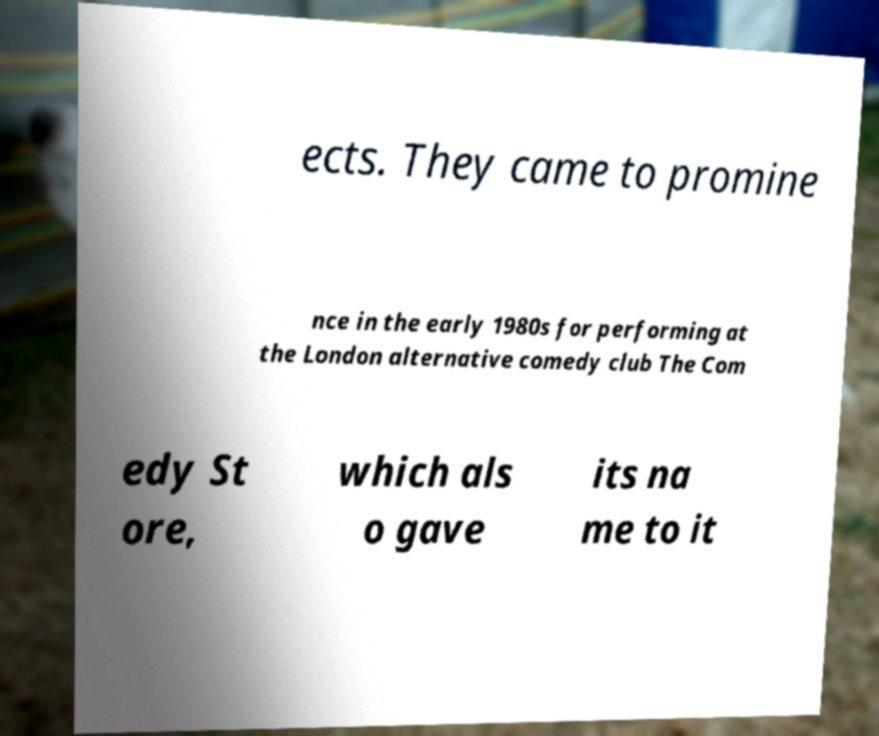For documentation purposes, I need the text within this image transcribed. Could you provide that? ects. They came to promine nce in the early 1980s for performing at the London alternative comedy club The Com edy St ore, which als o gave its na me to it 